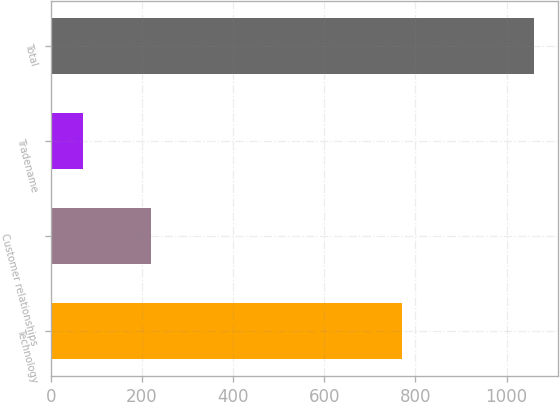<chart> <loc_0><loc_0><loc_500><loc_500><bar_chart><fcel>Technology<fcel>Customer relationships<fcel>Tradename<fcel>Total<nl><fcel>770<fcel>220<fcel>70<fcel>1060<nl></chart> 